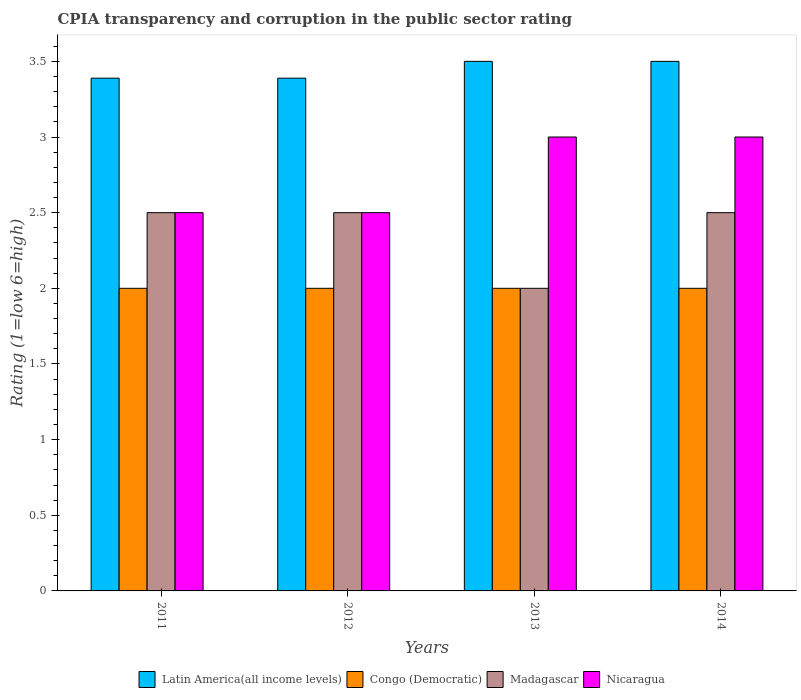How many groups of bars are there?
Keep it short and to the point. 4. Are the number of bars on each tick of the X-axis equal?
Ensure brevity in your answer.  Yes. How many bars are there on the 1st tick from the right?
Your answer should be very brief. 4. What is the label of the 1st group of bars from the left?
Offer a terse response. 2011. What is the CPIA rating in Latin America(all income levels) in 2011?
Offer a very short reply. 3.39. Across all years, what is the maximum CPIA rating in Nicaragua?
Keep it short and to the point. 3. In which year was the CPIA rating in Congo (Democratic) maximum?
Give a very brief answer. 2011. In which year was the CPIA rating in Congo (Democratic) minimum?
Offer a terse response. 2011. What is the total CPIA rating in Latin America(all income levels) in the graph?
Provide a short and direct response. 13.78. What is the difference between the CPIA rating in Madagascar in 2011 and that in 2014?
Your answer should be compact. 0. What is the difference between the CPIA rating in Congo (Democratic) in 2011 and the CPIA rating in Madagascar in 2013?
Your answer should be compact. 0. What is the average CPIA rating in Nicaragua per year?
Offer a very short reply. 2.75. In the year 2012, what is the difference between the CPIA rating in Latin America(all income levels) and CPIA rating in Nicaragua?
Keep it short and to the point. 0.89. What is the ratio of the CPIA rating in Congo (Democratic) in 2012 to that in 2014?
Provide a succinct answer. 1. Is the difference between the CPIA rating in Latin America(all income levels) in 2012 and 2014 greater than the difference between the CPIA rating in Nicaragua in 2012 and 2014?
Make the answer very short. Yes. What is the difference between the highest and the lowest CPIA rating in Latin America(all income levels)?
Give a very brief answer. 0.11. What does the 4th bar from the left in 2011 represents?
Ensure brevity in your answer.  Nicaragua. What does the 3rd bar from the right in 2011 represents?
Your response must be concise. Congo (Democratic). Is it the case that in every year, the sum of the CPIA rating in Madagascar and CPIA rating in Congo (Democratic) is greater than the CPIA rating in Nicaragua?
Make the answer very short. Yes. How many years are there in the graph?
Provide a succinct answer. 4. What is the difference between two consecutive major ticks on the Y-axis?
Keep it short and to the point. 0.5. Are the values on the major ticks of Y-axis written in scientific E-notation?
Provide a succinct answer. No. Does the graph contain any zero values?
Ensure brevity in your answer.  No. Where does the legend appear in the graph?
Provide a short and direct response. Bottom center. How many legend labels are there?
Offer a terse response. 4. How are the legend labels stacked?
Your answer should be compact. Horizontal. What is the title of the graph?
Your response must be concise. CPIA transparency and corruption in the public sector rating. Does "Rwanda" appear as one of the legend labels in the graph?
Ensure brevity in your answer.  No. What is the label or title of the X-axis?
Your response must be concise. Years. What is the label or title of the Y-axis?
Make the answer very short. Rating (1=low 6=high). What is the Rating (1=low 6=high) in Latin America(all income levels) in 2011?
Offer a very short reply. 3.39. What is the Rating (1=low 6=high) in Congo (Democratic) in 2011?
Your answer should be compact. 2. What is the Rating (1=low 6=high) of Nicaragua in 2011?
Provide a short and direct response. 2.5. What is the Rating (1=low 6=high) in Latin America(all income levels) in 2012?
Offer a terse response. 3.39. What is the Rating (1=low 6=high) in Congo (Democratic) in 2013?
Offer a terse response. 2. What is the Rating (1=low 6=high) in Nicaragua in 2013?
Provide a short and direct response. 3. What is the Rating (1=low 6=high) in Latin America(all income levels) in 2014?
Your answer should be very brief. 3.5. What is the Rating (1=low 6=high) of Congo (Democratic) in 2014?
Give a very brief answer. 2. What is the Rating (1=low 6=high) in Madagascar in 2014?
Make the answer very short. 2.5. What is the Rating (1=low 6=high) in Nicaragua in 2014?
Provide a succinct answer. 3. Across all years, what is the maximum Rating (1=low 6=high) of Latin America(all income levels)?
Keep it short and to the point. 3.5. Across all years, what is the maximum Rating (1=low 6=high) in Congo (Democratic)?
Provide a succinct answer. 2. Across all years, what is the maximum Rating (1=low 6=high) of Madagascar?
Provide a succinct answer. 2.5. Across all years, what is the maximum Rating (1=low 6=high) of Nicaragua?
Ensure brevity in your answer.  3. Across all years, what is the minimum Rating (1=low 6=high) in Latin America(all income levels)?
Your answer should be very brief. 3.39. Across all years, what is the minimum Rating (1=low 6=high) of Madagascar?
Your answer should be compact. 2. What is the total Rating (1=low 6=high) of Latin America(all income levels) in the graph?
Make the answer very short. 13.78. What is the total Rating (1=low 6=high) in Nicaragua in the graph?
Provide a succinct answer. 11. What is the difference between the Rating (1=low 6=high) of Madagascar in 2011 and that in 2012?
Give a very brief answer. 0. What is the difference between the Rating (1=low 6=high) of Nicaragua in 2011 and that in 2012?
Provide a succinct answer. 0. What is the difference between the Rating (1=low 6=high) of Latin America(all income levels) in 2011 and that in 2013?
Your answer should be compact. -0.11. What is the difference between the Rating (1=low 6=high) in Congo (Democratic) in 2011 and that in 2013?
Your answer should be compact. 0. What is the difference between the Rating (1=low 6=high) of Madagascar in 2011 and that in 2013?
Make the answer very short. 0.5. What is the difference between the Rating (1=low 6=high) in Latin America(all income levels) in 2011 and that in 2014?
Your answer should be very brief. -0.11. What is the difference between the Rating (1=low 6=high) in Congo (Democratic) in 2011 and that in 2014?
Offer a terse response. 0. What is the difference between the Rating (1=low 6=high) of Madagascar in 2011 and that in 2014?
Offer a very short reply. 0. What is the difference between the Rating (1=low 6=high) in Latin America(all income levels) in 2012 and that in 2013?
Make the answer very short. -0.11. What is the difference between the Rating (1=low 6=high) of Congo (Democratic) in 2012 and that in 2013?
Give a very brief answer. 0. What is the difference between the Rating (1=low 6=high) of Latin America(all income levels) in 2012 and that in 2014?
Provide a succinct answer. -0.11. What is the difference between the Rating (1=low 6=high) in Congo (Democratic) in 2012 and that in 2014?
Offer a terse response. 0. What is the difference between the Rating (1=low 6=high) in Madagascar in 2012 and that in 2014?
Ensure brevity in your answer.  0. What is the difference between the Rating (1=low 6=high) in Congo (Democratic) in 2013 and that in 2014?
Your response must be concise. 0. What is the difference between the Rating (1=low 6=high) in Madagascar in 2013 and that in 2014?
Offer a very short reply. -0.5. What is the difference between the Rating (1=low 6=high) of Nicaragua in 2013 and that in 2014?
Provide a succinct answer. 0. What is the difference between the Rating (1=low 6=high) of Latin America(all income levels) in 2011 and the Rating (1=low 6=high) of Congo (Democratic) in 2012?
Ensure brevity in your answer.  1.39. What is the difference between the Rating (1=low 6=high) of Latin America(all income levels) in 2011 and the Rating (1=low 6=high) of Madagascar in 2012?
Your response must be concise. 0.89. What is the difference between the Rating (1=low 6=high) in Latin America(all income levels) in 2011 and the Rating (1=low 6=high) in Nicaragua in 2012?
Make the answer very short. 0.89. What is the difference between the Rating (1=low 6=high) in Congo (Democratic) in 2011 and the Rating (1=low 6=high) in Madagascar in 2012?
Keep it short and to the point. -0.5. What is the difference between the Rating (1=low 6=high) in Madagascar in 2011 and the Rating (1=low 6=high) in Nicaragua in 2012?
Offer a terse response. 0. What is the difference between the Rating (1=low 6=high) of Latin America(all income levels) in 2011 and the Rating (1=low 6=high) of Congo (Democratic) in 2013?
Give a very brief answer. 1.39. What is the difference between the Rating (1=low 6=high) in Latin America(all income levels) in 2011 and the Rating (1=low 6=high) in Madagascar in 2013?
Offer a terse response. 1.39. What is the difference between the Rating (1=low 6=high) in Latin America(all income levels) in 2011 and the Rating (1=low 6=high) in Nicaragua in 2013?
Keep it short and to the point. 0.39. What is the difference between the Rating (1=low 6=high) in Madagascar in 2011 and the Rating (1=low 6=high) in Nicaragua in 2013?
Your answer should be compact. -0.5. What is the difference between the Rating (1=low 6=high) in Latin America(all income levels) in 2011 and the Rating (1=low 6=high) in Congo (Democratic) in 2014?
Ensure brevity in your answer.  1.39. What is the difference between the Rating (1=low 6=high) of Latin America(all income levels) in 2011 and the Rating (1=low 6=high) of Nicaragua in 2014?
Ensure brevity in your answer.  0.39. What is the difference between the Rating (1=low 6=high) in Congo (Democratic) in 2011 and the Rating (1=low 6=high) in Madagascar in 2014?
Your response must be concise. -0.5. What is the difference between the Rating (1=low 6=high) in Congo (Democratic) in 2011 and the Rating (1=low 6=high) in Nicaragua in 2014?
Offer a very short reply. -1. What is the difference between the Rating (1=low 6=high) in Latin America(all income levels) in 2012 and the Rating (1=low 6=high) in Congo (Democratic) in 2013?
Make the answer very short. 1.39. What is the difference between the Rating (1=low 6=high) in Latin America(all income levels) in 2012 and the Rating (1=low 6=high) in Madagascar in 2013?
Offer a very short reply. 1.39. What is the difference between the Rating (1=low 6=high) of Latin America(all income levels) in 2012 and the Rating (1=low 6=high) of Nicaragua in 2013?
Keep it short and to the point. 0.39. What is the difference between the Rating (1=low 6=high) of Congo (Democratic) in 2012 and the Rating (1=low 6=high) of Madagascar in 2013?
Your response must be concise. 0. What is the difference between the Rating (1=low 6=high) in Congo (Democratic) in 2012 and the Rating (1=low 6=high) in Nicaragua in 2013?
Provide a succinct answer. -1. What is the difference between the Rating (1=low 6=high) of Madagascar in 2012 and the Rating (1=low 6=high) of Nicaragua in 2013?
Make the answer very short. -0.5. What is the difference between the Rating (1=low 6=high) in Latin America(all income levels) in 2012 and the Rating (1=low 6=high) in Congo (Democratic) in 2014?
Offer a very short reply. 1.39. What is the difference between the Rating (1=low 6=high) in Latin America(all income levels) in 2012 and the Rating (1=low 6=high) in Madagascar in 2014?
Provide a short and direct response. 0.89. What is the difference between the Rating (1=low 6=high) of Latin America(all income levels) in 2012 and the Rating (1=low 6=high) of Nicaragua in 2014?
Provide a short and direct response. 0.39. What is the difference between the Rating (1=low 6=high) of Congo (Democratic) in 2012 and the Rating (1=low 6=high) of Madagascar in 2014?
Offer a terse response. -0.5. What is the difference between the Rating (1=low 6=high) in Congo (Democratic) in 2012 and the Rating (1=low 6=high) in Nicaragua in 2014?
Offer a terse response. -1. What is the difference between the Rating (1=low 6=high) in Latin America(all income levels) in 2013 and the Rating (1=low 6=high) in Congo (Democratic) in 2014?
Your answer should be very brief. 1.5. What is the difference between the Rating (1=low 6=high) of Latin America(all income levels) in 2013 and the Rating (1=low 6=high) of Nicaragua in 2014?
Provide a short and direct response. 0.5. What is the difference between the Rating (1=low 6=high) in Congo (Democratic) in 2013 and the Rating (1=low 6=high) in Madagascar in 2014?
Your answer should be compact. -0.5. What is the average Rating (1=low 6=high) of Latin America(all income levels) per year?
Ensure brevity in your answer.  3.44. What is the average Rating (1=low 6=high) of Congo (Democratic) per year?
Provide a short and direct response. 2. What is the average Rating (1=low 6=high) in Madagascar per year?
Provide a short and direct response. 2.38. What is the average Rating (1=low 6=high) of Nicaragua per year?
Offer a very short reply. 2.75. In the year 2011, what is the difference between the Rating (1=low 6=high) in Latin America(all income levels) and Rating (1=low 6=high) in Congo (Democratic)?
Offer a terse response. 1.39. In the year 2011, what is the difference between the Rating (1=low 6=high) of Latin America(all income levels) and Rating (1=low 6=high) of Madagascar?
Your response must be concise. 0.89. In the year 2011, what is the difference between the Rating (1=low 6=high) of Congo (Democratic) and Rating (1=low 6=high) of Madagascar?
Offer a very short reply. -0.5. In the year 2011, what is the difference between the Rating (1=low 6=high) in Congo (Democratic) and Rating (1=low 6=high) in Nicaragua?
Your answer should be very brief. -0.5. In the year 2011, what is the difference between the Rating (1=low 6=high) of Madagascar and Rating (1=low 6=high) of Nicaragua?
Your answer should be compact. 0. In the year 2012, what is the difference between the Rating (1=low 6=high) in Latin America(all income levels) and Rating (1=low 6=high) in Congo (Democratic)?
Provide a succinct answer. 1.39. In the year 2012, what is the difference between the Rating (1=low 6=high) of Latin America(all income levels) and Rating (1=low 6=high) of Nicaragua?
Provide a short and direct response. 0.89. In the year 2012, what is the difference between the Rating (1=low 6=high) of Congo (Democratic) and Rating (1=low 6=high) of Madagascar?
Your answer should be very brief. -0.5. In the year 2013, what is the difference between the Rating (1=low 6=high) of Latin America(all income levels) and Rating (1=low 6=high) of Congo (Democratic)?
Your answer should be very brief. 1.5. In the year 2013, what is the difference between the Rating (1=low 6=high) in Latin America(all income levels) and Rating (1=low 6=high) in Nicaragua?
Your answer should be compact. 0.5. In the year 2013, what is the difference between the Rating (1=low 6=high) of Congo (Democratic) and Rating (1=low 6=high) of Madagascar?
Keep it short and to the point. 0. In the year 2013, what is the difference between the Rating (1=low 6=high) in Congo (Democratic) and Rating (1=low 6=high) in Nicaragua?
Ensure brevity in your answer.  -1. In the year 2014, what is the difference between the Rating (1=low 6=high) in Latin America(all income levels) and Rating (1=low 6=high) in Congo (Democratic)?
Your response must be concise. 1.5. What is the ratio of the Rating (1=low 6=high) of Latin America(all income levels) in 2011 to that in 2012?
Your response must be concise. 1. What is the ratio of the Rating (1=low 6=high) in Congo (Democratic) in 2011 to that in 2012?
Provide a short and direct response. 1. What is the ratio of the Rating (1=low 6=high) of Madagascar in 2011 to that in 2012?
Your answer should be very brief. 1. What is the ratio of the Rating (1=low 6=high) in Latin America(all income levels) in 2011 to that in 2013?
Give a very brief answer. 0.97. What is the ratio of the Rating (1=low 6=high) of Latin America(all income levels) in 2011 to that in 2014?
Make the answer very short. 0.97. What is the ratio of the Rating (1=low 6=high) in Congo (Democratic) in 2011 to that in 2014?
Make the answer very short. 1. What is the ratio of the Rating (1=low 6=high) of Madagascar in 2011 to that in 2014?
Ensure brevity in your answer.  1. What is the ratio of the Rating (1=low 6=high) of Nicaragua in 2011 to that in 2014?
Offer a very short reply. 0.83. What is the ratio of the Rating (1=low 6=high) of Latin America(all income levels) in 2012 to that in 2013?
Your response must be concise. 0.97. What is the ratio of the Rating (1=low 6=high) in Congo (Democratic) in 2012 to that in 2013?
Offer a terse response. 1. What is the ratio of the Rating (1=low 6=high) of Madagascar in 2012 to that in 2013?
Your response must be concise. 1.25. What is the ratio of the Rating (1=low 6=high) of Nicaragua in 2012 to that in 2013?
Keep it short and to the point. 0.83. What is the ratio of the Rating (1=low 6=high) in Latin America(all income levels) in 2012 to that in 2014?
Offer a terse response. 0.97. What is the ratio of the Rating (1=low 6=high) of Nicaragua in 2012 to that in 2014?
Offer a terse response. 0.83. What is the ratio of the Rating (1=low 6=high) in Congo (Democratic) in 2013 to that in 2014?
Provide a succinct answer. 1. What is the ratio of the Rating (1=low 6=high) in Nicaragua in 2013 to that in 2014?
Your answer should be very brief. 1. What is the difference between the highest and the second highest Rating (1=low 6=high) in Madagascar?
Ensure brevity in your answer.  0. What is the difference between the highest and the lowest Rating (1=low 6=high) in Latin America(all income levels)?
Keep it short and to the point. 0.11. What is the difference between the highest and the lowest Rating (1=low 6=high) in Congo (Democratic)?
Offer a terse response. 0. 